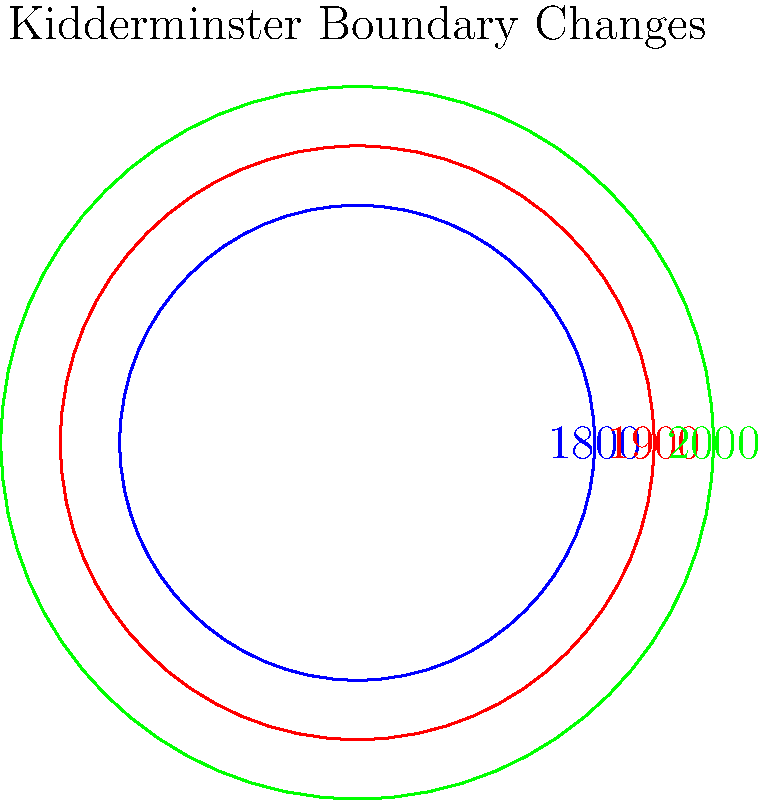Based on the map overlay showing Kidderminster's changing boundaries, which century saw the most significant expansion of the town's area? To determine which century saw the most significant expansion of Kidderminster's area, we need to compare the changes between the three time periods shown:

1. The innermost blue circle represents Kidderminster's boundary in 1800.
2. The middle red circle represents the boundary in 1900.
3. The outermost green circle represents the boundary in 2000.

Step 1: Analyze the change from 1800 to 1900 (19th century)
- There is a noticeable increase in area from the blue circle to the red circle.

Step 2: Analyze the change from 1900 to 2000 (20th century)
- There is a larger increase in area from the red circle to the green circle.

Step 3: Compare the two expansions
- The expansion during the 20th century (1900 to 2000) appears to be greater than the expansion during the 19th century (1800 to 1900).

Step 4: Consider the scale of expansion
- The 20th century expansion added a larger ring of area around the entire 1900 boundary, indicating a more significant growth in all directions.

Therefore, based on the visual representation, the 20th century (1900 to 2000) saw the most significant expansion of Kidderminster's area.
Answer: 20th century 